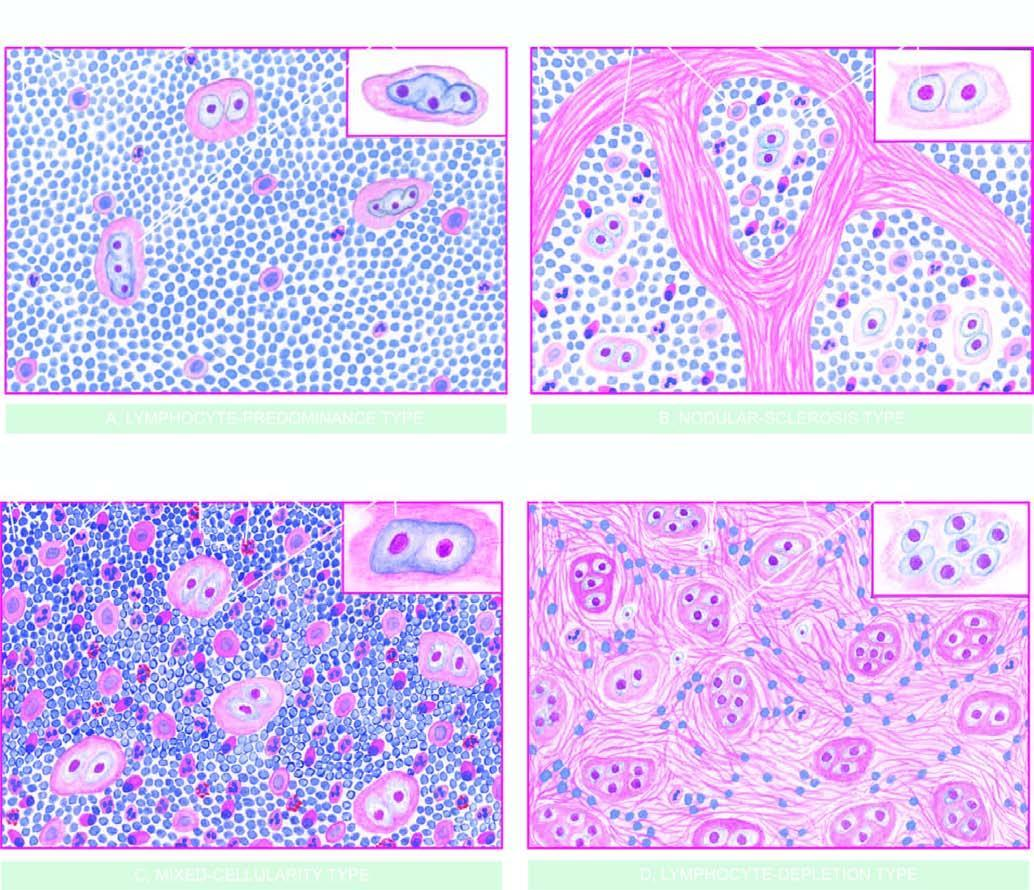what shows the morphologic variant of rs cell seen more often in particular histologic type?
Answer the question using a single word or phrase. The inset on right side of each type 